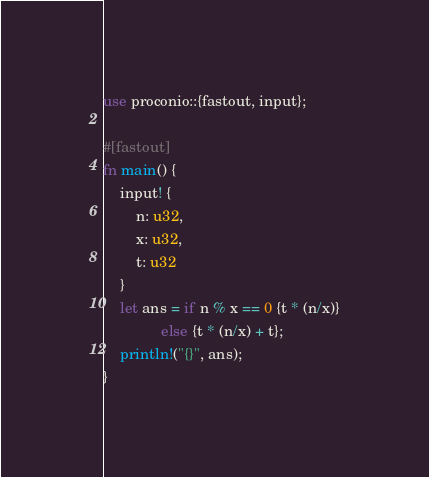Convert code to text. <code><loc_0><loc_0><loc_500><loc_500><_Rust_>use proconio::{fastout, input};

#[fastout]
fn main() {
    input! {
        n: u32,
        x: u32,
        t: u32
    }
    let ans = if n % x == 0 {t * (n/x)}
              else {t * (n/x) + t};
    println!("{}", ans);
}
</code> 